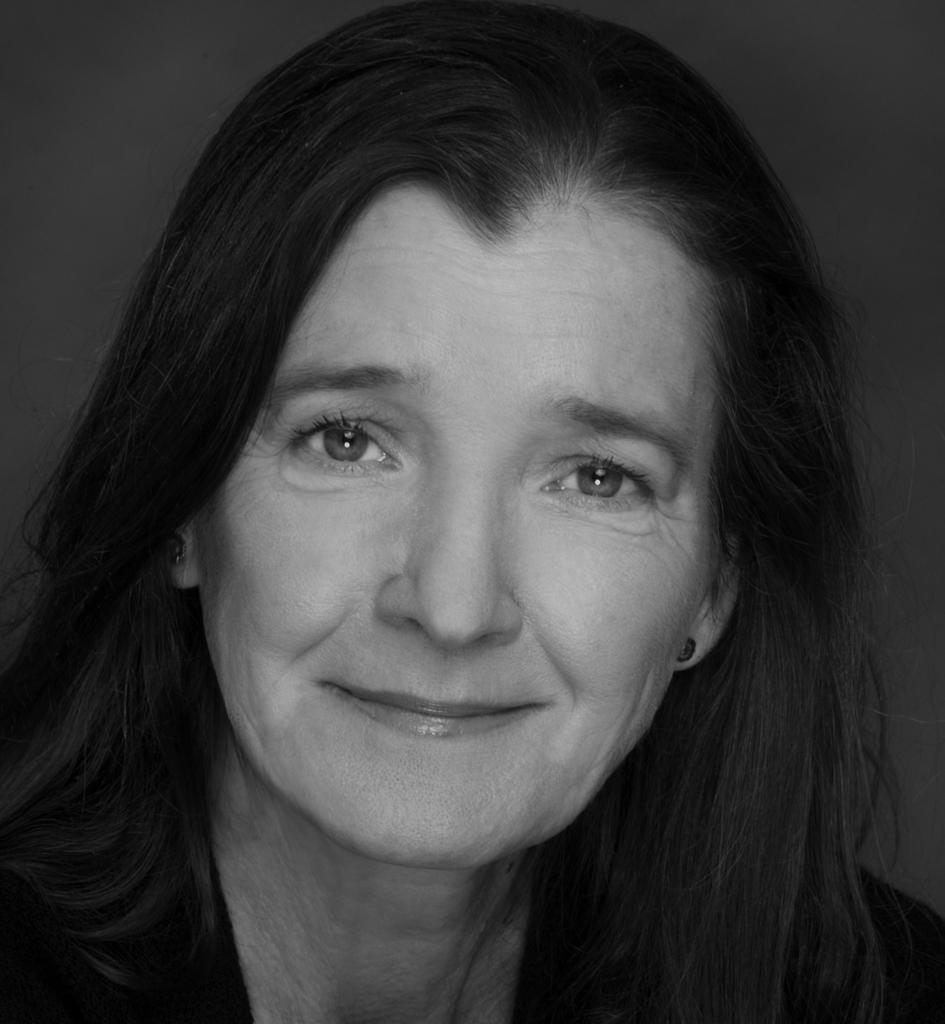What is the color scheme of the image? The image is black and white. Who is the main subject in the image? There is a woman in the center of the image. What type of interest does the woman have in the yam in the image? There is no yam present in the image, and therefore no such interest can be observed. 